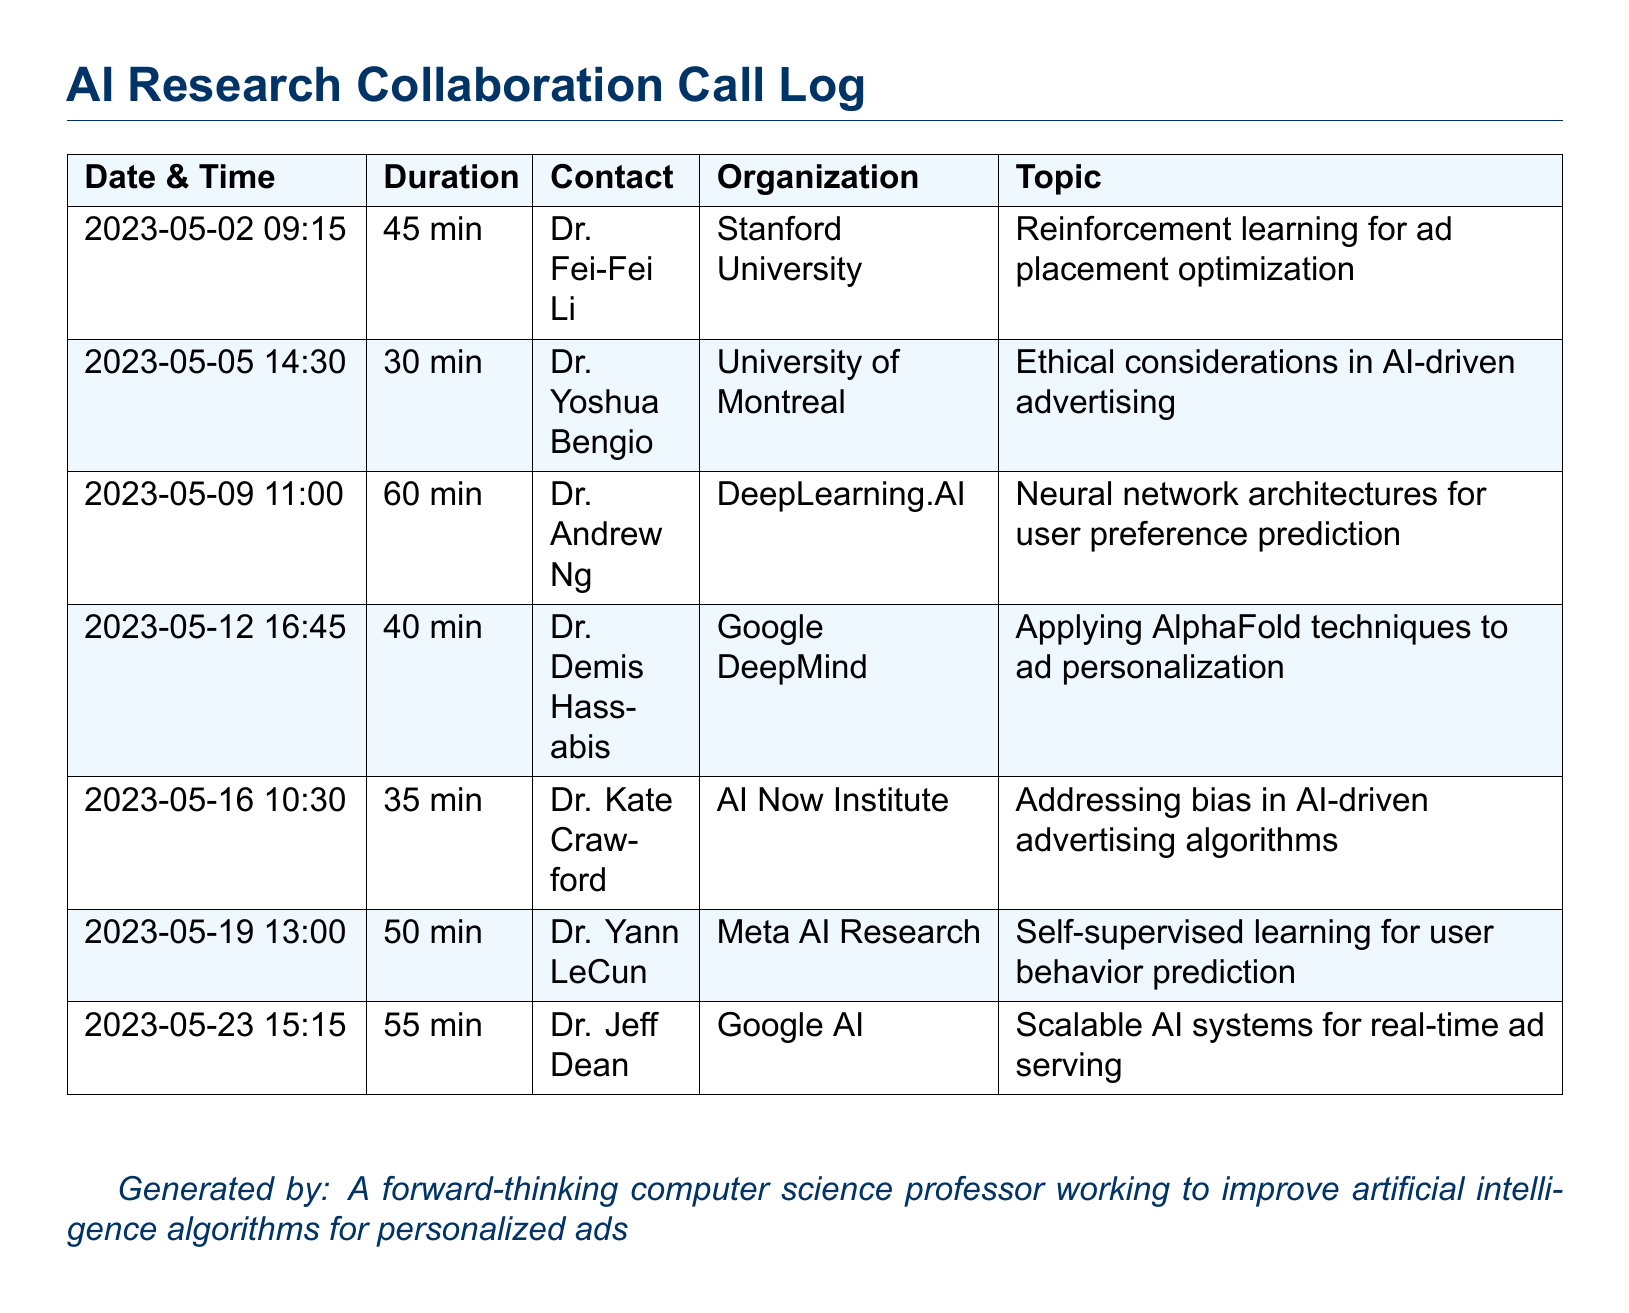What was the duration of the call with Dr. Fei-Fei Li? The duration of the call with Dr. Fei-Fei Li is specified in the document as 45 minutes.
Answer: 45 min Who is the contact for the call on May 12, 2023? The contact for the call on May 12, 2023, is provided as Dr. Demis Hassabis.
Answer: Dr. Demis Hassabis What topic was discussed during the call with Dr. Kate Crawford? The document states that the topic discussed during the call with Dr. Kate Crawford was addressing bias in AI-driven advertising algorithms.
Answer: Addressing bias in AI-driven advertising algorithms Which organization is Dr. Andrew Ng associated with? Dr. Andrew Ng's association is noted as DeepLearning.AI in the document.
Answer: DeepLearning.AI What is the total duration of calls listed in the document? The total duration can be calculated by summing the individual durations: 45 + 30 + 60 + 40 + 35 + 50 + 55 = 315 minutes.
Answer: 315 min Which call had the longest duration? By reviewing the listed call durations, the longest call is with Dr. Andrew Ng, lasting 60 minutes.
Answer: 60 min How many times did Dr. Jeff Dean appear in the call log? The call log lists only one entry for Dr. Jeff Dean, indicating he appeared once.
Answer: Once What date did the call with Dr. Yann LeCun take place? The date of the call with Dr. Yann LeCun is mentioned as May 19, 2023.
Answer: 2023-05-19 What is the main focus of the call with Dr. Yoshua Bengio? The document specifies that the main focus of the call with Dr. Yoshua Bengio was ethical considerations in AI-driven advertising.
Answer: Ethical considerations in AI-driven advertising 